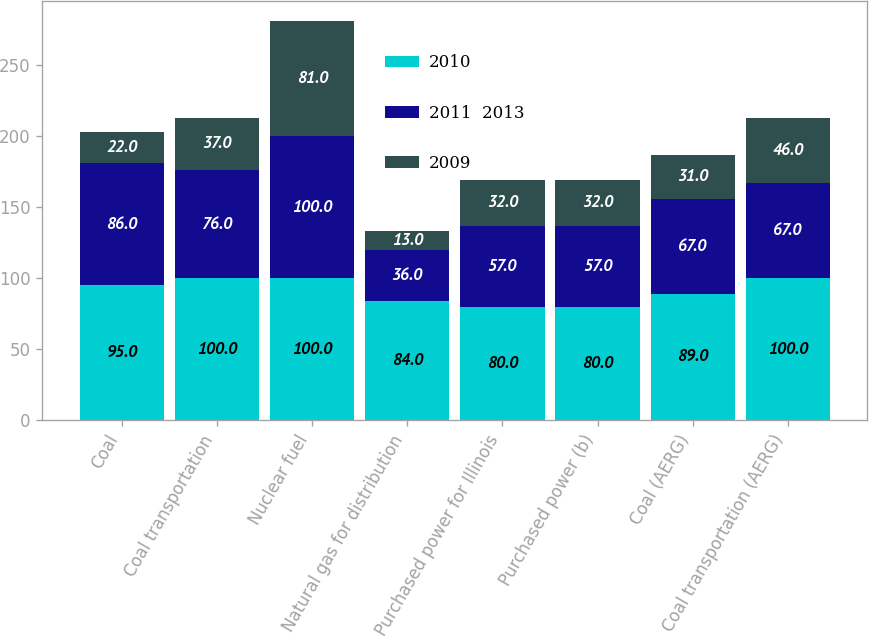<chart> <loc_0><loc_0><loc_500><loc_500><stacked_bar_chart><ecel><fcel>Coal<fcel>Coal transportation<fcel>Nuclear fuel<fcel>Natural gas for distribution<fcel>Purchased power for Illinois<fcel>Purchased power (b)<fcel>Coal (AERG)<fcel>Coal transportation (AERG)<nl><fcel>2010<fcel>95<fcel>100<fcel>100<fcel>84<fcel>80<fcel>80<fcel>89<fcel>100<nl><fcel>2011  2013<fcel>86<fcel>76<fcel>100<fcel>36<fcel>57<fcel>57<fcel>67<fcel>67<nl><fcel>2009<fcel>22<fcel>37<fcel>81<fcel>13<fcel>32<fcel>32<fcel>31<fcel>46<nl></chart> 